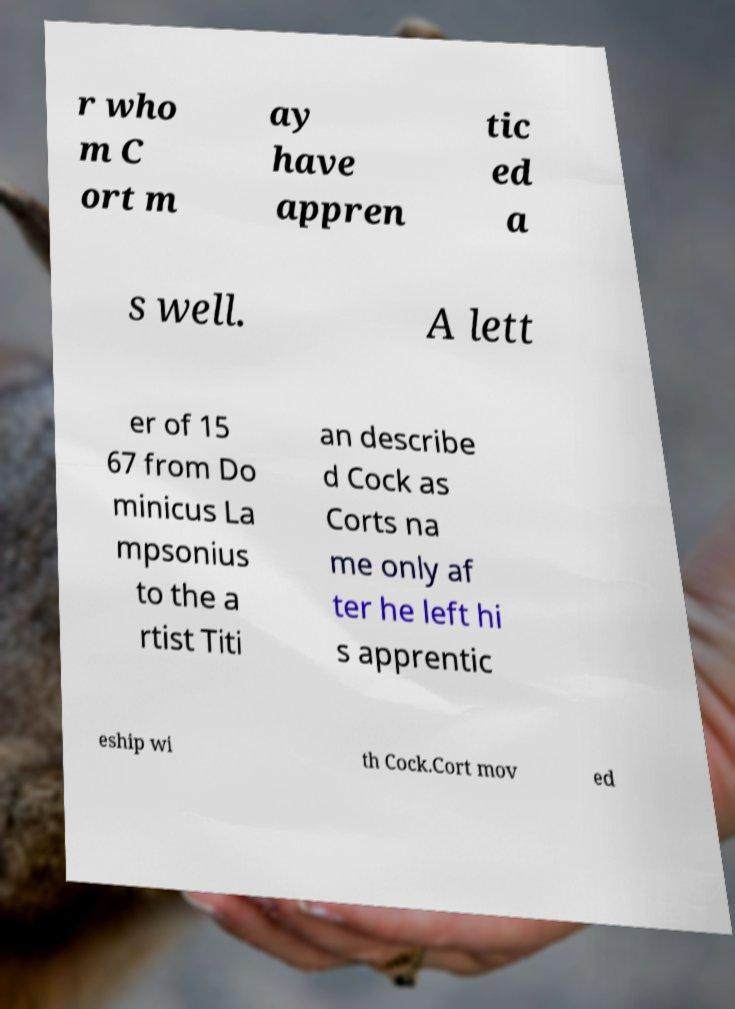Could you assist in decoding the text presented in this image and type it out clearly? r who m C ort m ay have appren tic ed a s well. A lett er of 15 67 from Do minicus La mpsonius to the a rtist Titi an describe d Cock as Corts na me only af ter he left hi s apprentic eship wi th Cock.Cort mov ed 